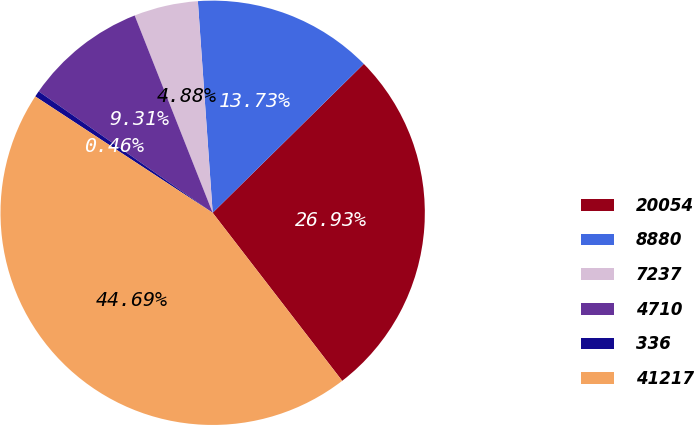<chart> <loc_0><loc_0><loc_500><loc_500><pie_chart><fcel>20054<fcel>8880<fcel>7237<fcel>4710<fcel>336<fcel>41217<nl><fcel>26.93%<fcel>13.73%<fcel>4.88%<fcel>9.31%<fcel>0.46%<fcel>44.69%<nl></chart> 